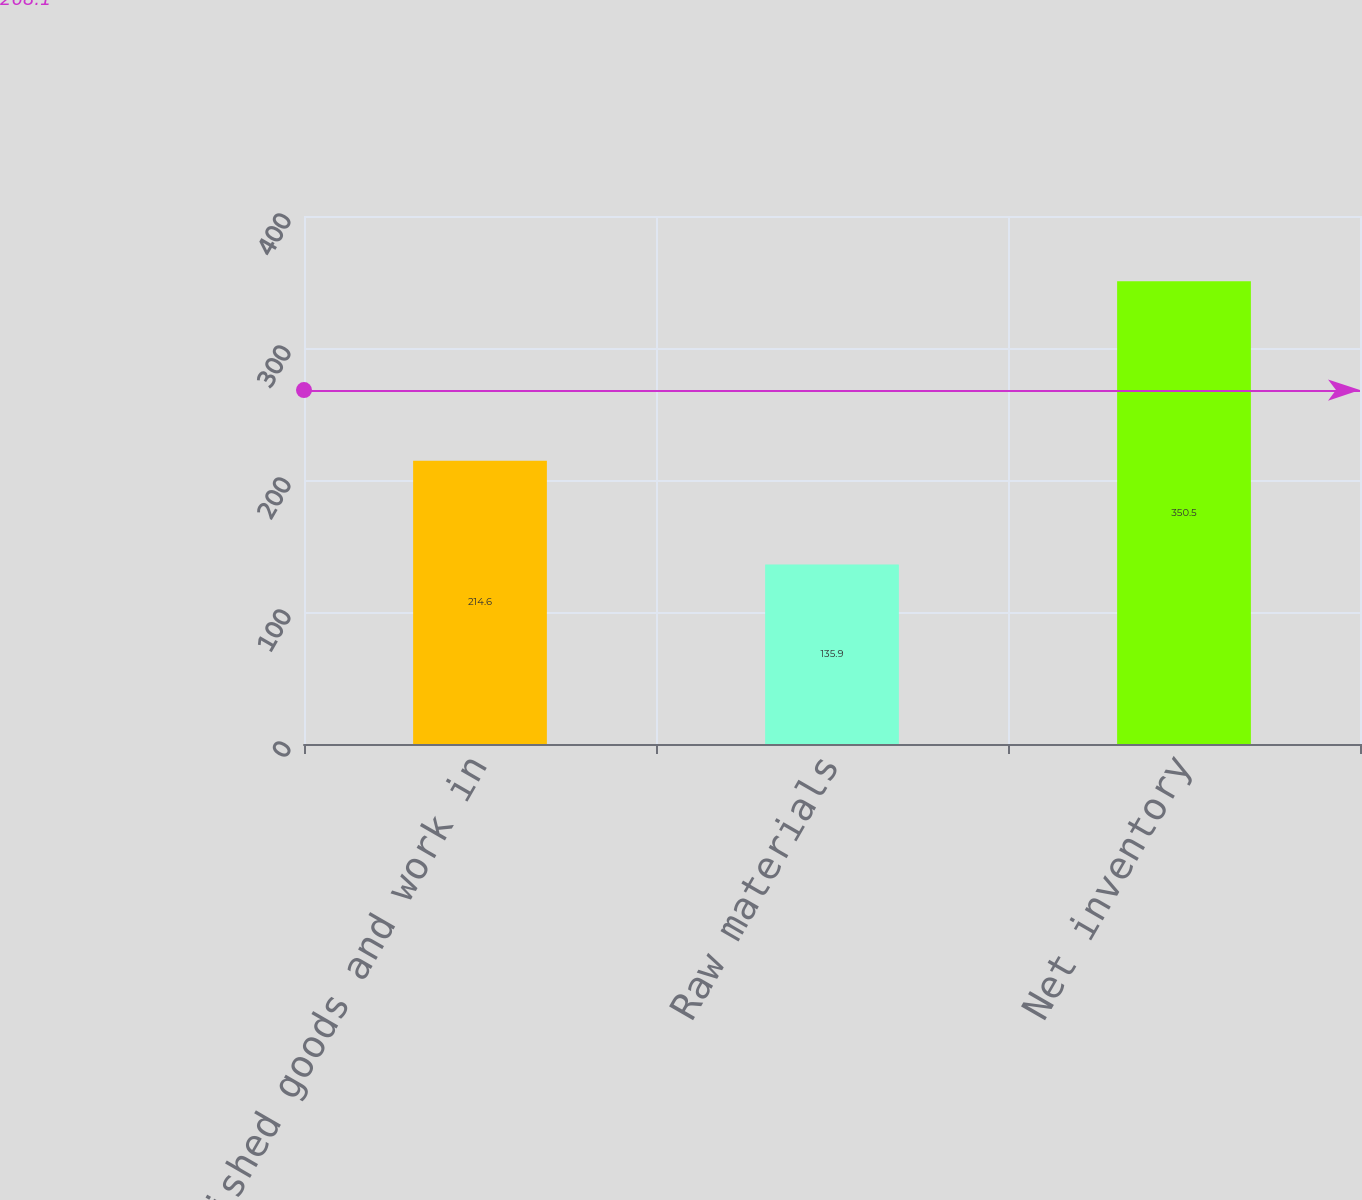<chart> <loc_0><loc_0><loc_500><loc_500><bar_chart><fcel>Finished goods and work in<fcel>Raw materials<fcel>Net inventory<nl><fcel>214.6<fcel>135.9<fcel>350.5<nl></chart> 